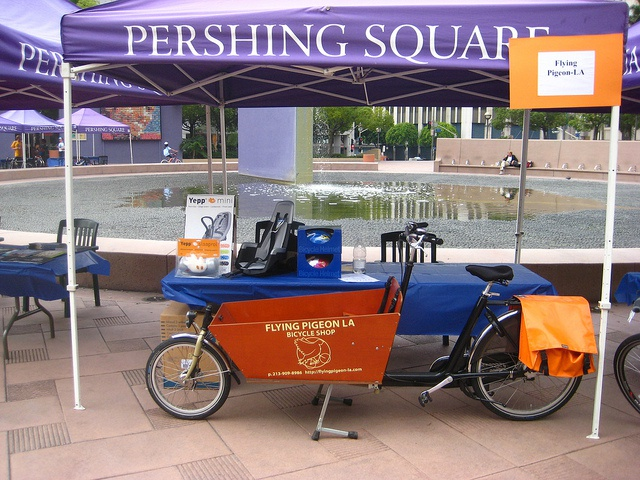Describe the objects in this image and their specific colors. I can see bicycle in lavender, brown, black, and gray tones, dining table in lavender, navy, gray, darkblue, and blue tones, dining table in lavender, navy, gray, black, and darkblue tones, bicycle in lavender, black, and gray tones, and chair in lavender, black, lightgray, darkgray, and gray tones in this image. 